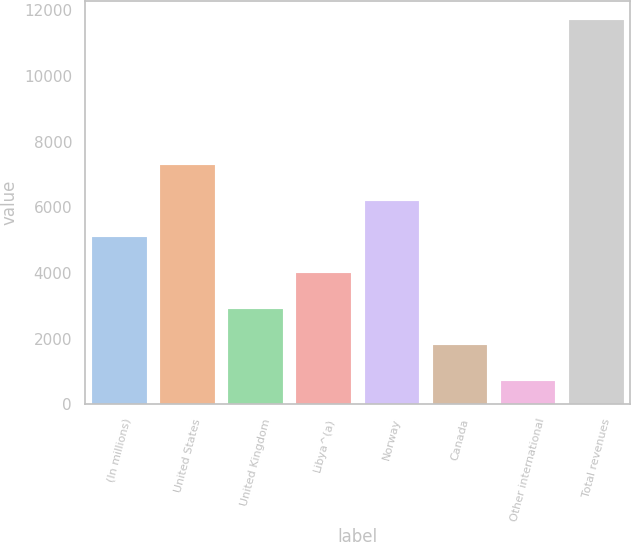Convert chart to OTSL. <chart><loc_0><loc_0><loc_500><loc_500><bar_chart><fcel>(In millions)<fcel>United States<fcel>United Kingdom<fcel>Libya^(a)<fcel>Norway<fcel>Canada<fcel>Other international<fcel>Total revenues<nl><fcel>5105<fcel>7300<fcel>2910<fcel>4007.5<fcel>6202.5<fcel>1812.5<fcel>715<fcel>11690<nl></chart> 